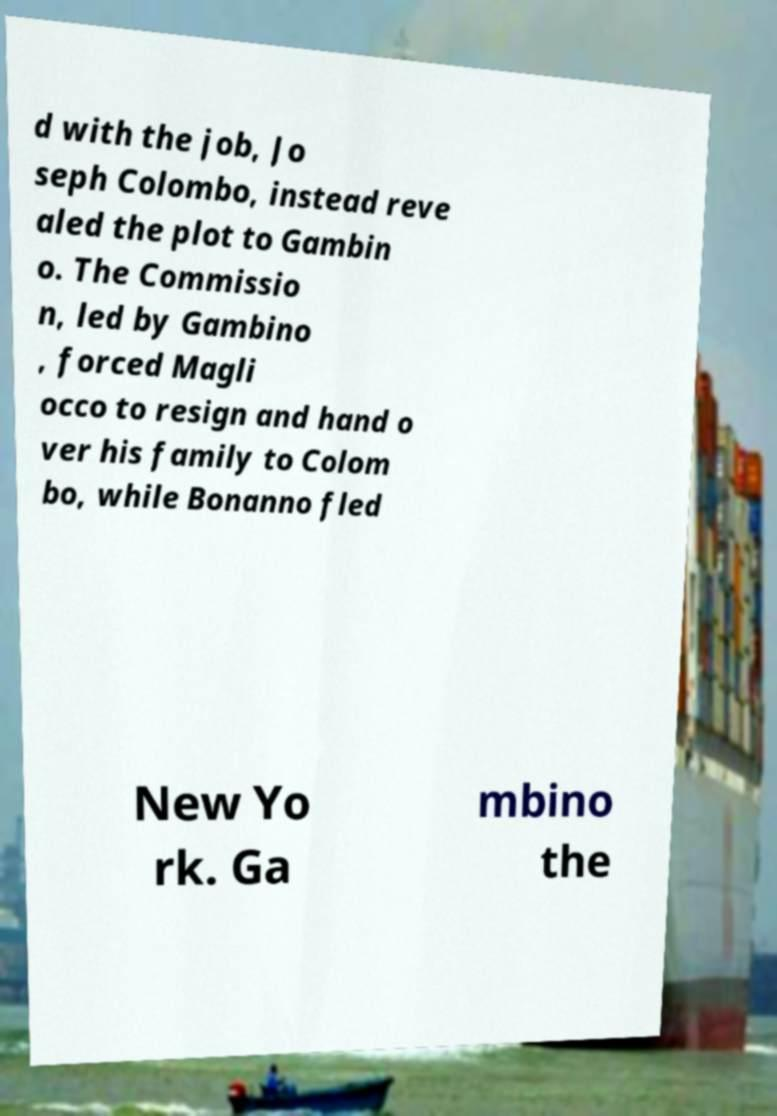Please identify and transcribe the text found in this image. d with the job, Jo seph Colombo, instead reve aled the plot to Gambin o. The Commissio n, led by Gambino , forced Magli occo to resign and hand o ver his family to Colom bo, while Bonanno fled New Yo rk. Ga mbino the 